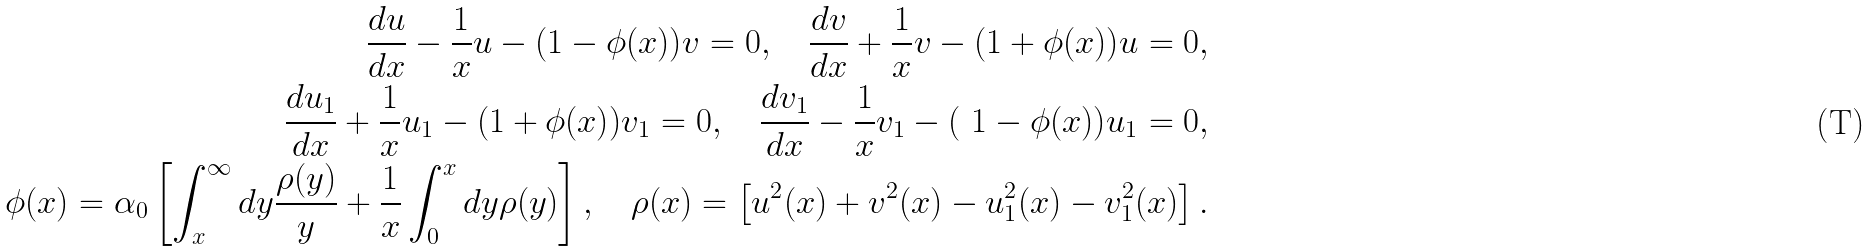<formula> <loc_0><loc_0><loc_500><loc_500>\frac { d u } { d x } - \frac { 1 } { x } u - ( 1 - \phi ( x ) ) v = 0 , \quad \frac { d v } { d x } + \frac { 1 } { x } v - ( 1 + \phi ( x ) ) u = 0 , \\ \frac { d u _ { 1 } } { d x } + \frac { 1 } { x } u _ { 1 } - ( 1 + \phi ( x ) ) v _ { 1 } = 0 , \quad \frac { d v _ { 1 } } { d x } - \frac { 1 } { x } v _ { 1 } - ( \ 1 - \phi ( x ) ) u _ { 1 } = 0 , \\ \phi ( x ) = \alpha _ { 0 } \left [ \int _ { x } ^ { \infty } d y \frac { \rho ( y ) } { y } + \frac { 1 } { x } \int _ { 0 } ^ { x } d y \rho ( y ) \right ] , \quad \rho ( x ) = \left [ u ^ { 2 } ( x ) + v ^ { 2 } ( x ) - u ^ { 2 } _ { 1 } ( x ) - v ^ { 2 } _ { 1 } ( x ) \right ] .</formula> 